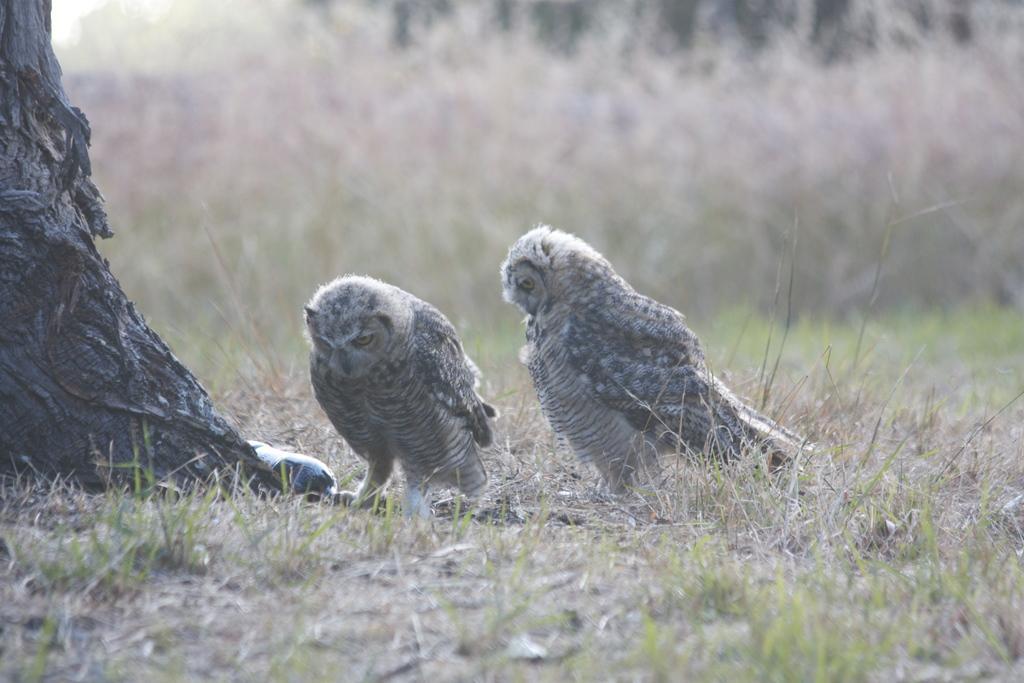Could you give a brief overview of what you see in this image? In this picture I can see there are two owls here and there is a bottle here and there is a tree here on the left and there are some plants in the backdrop. 